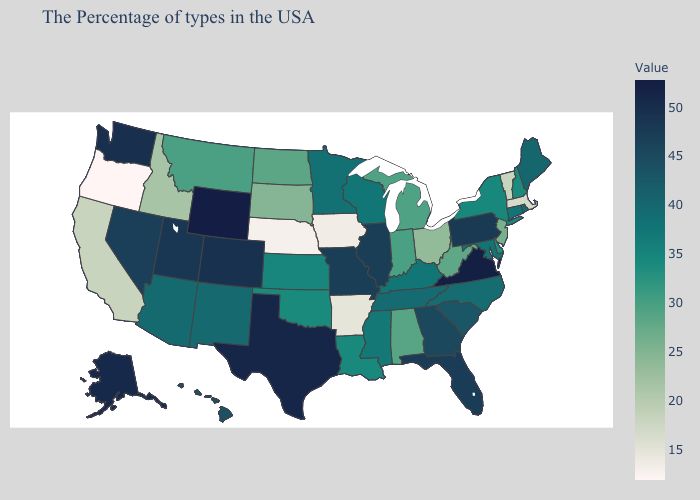Does Montana have a higher value than Wyoming?
Give a very brief answer. No. Is the legend a continuous bar?
Short answer required. Yes. Is the legend a continuous bar?
Quick response, please. Yes. Does Pennsylvania have a lower value than Wyoming?
Short answer required. Yes. Is the legend a continuous bar?
Keep it brief. Yes. Does Kansas have a lower value than South Dakota?
Keep it brief. No. 